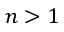Convert formula to latex. <formula><loc_0><loc_0><loc_500><loc_500>n > 1</formula> 